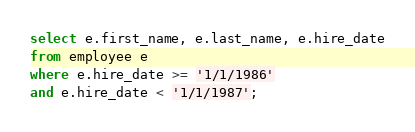<code> <loc_0><loc_0><loc_500><loc_500><_SQL_>
select e.first_name, e.last_name, e.hire_date
from employee e
where e.hire_date >= '1/1/1986' 
and e.hire_date < '1/1/1987';</code> 